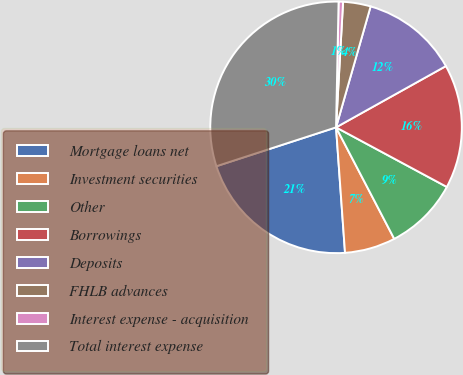Convert chart. <chart><loc_0><loc_0><loc_500><loc_500><pie_chart><fcel>Mortgage loans net<fcel>Investment securities<fcel>Other<fcel>Borrowings<fcel>Deposits<fcel>FHLB advances<fcel>Interest expense - acquisition<fcel>Total interest expense<nl><fcel>21.14%<fcel>6.52%<fcel>9.49%<fcel>15.95%<fcel>12.47%<fcel>3.54%<fcel>0.57%<fcel>30.32%<nl></chart> 